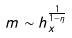<formula> <loc_0><loc_0><loc_500><loc_500>m \sim h _ { x } ^ { \frac { 1 } { 1 - \eta } }</formula> 